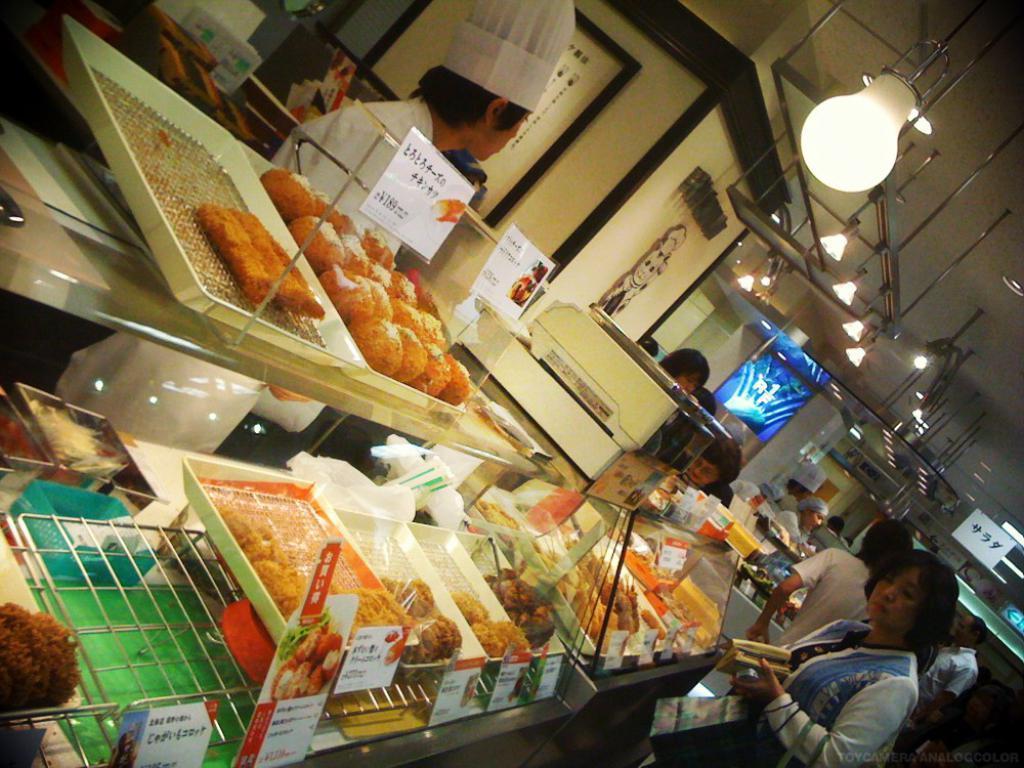How would you summarize this image in a sentence or two? In the foreground I can see a group of people and food items trays on a table. In the background I can see a wall, metal rods and lamps. This image is taken in a hotel. 